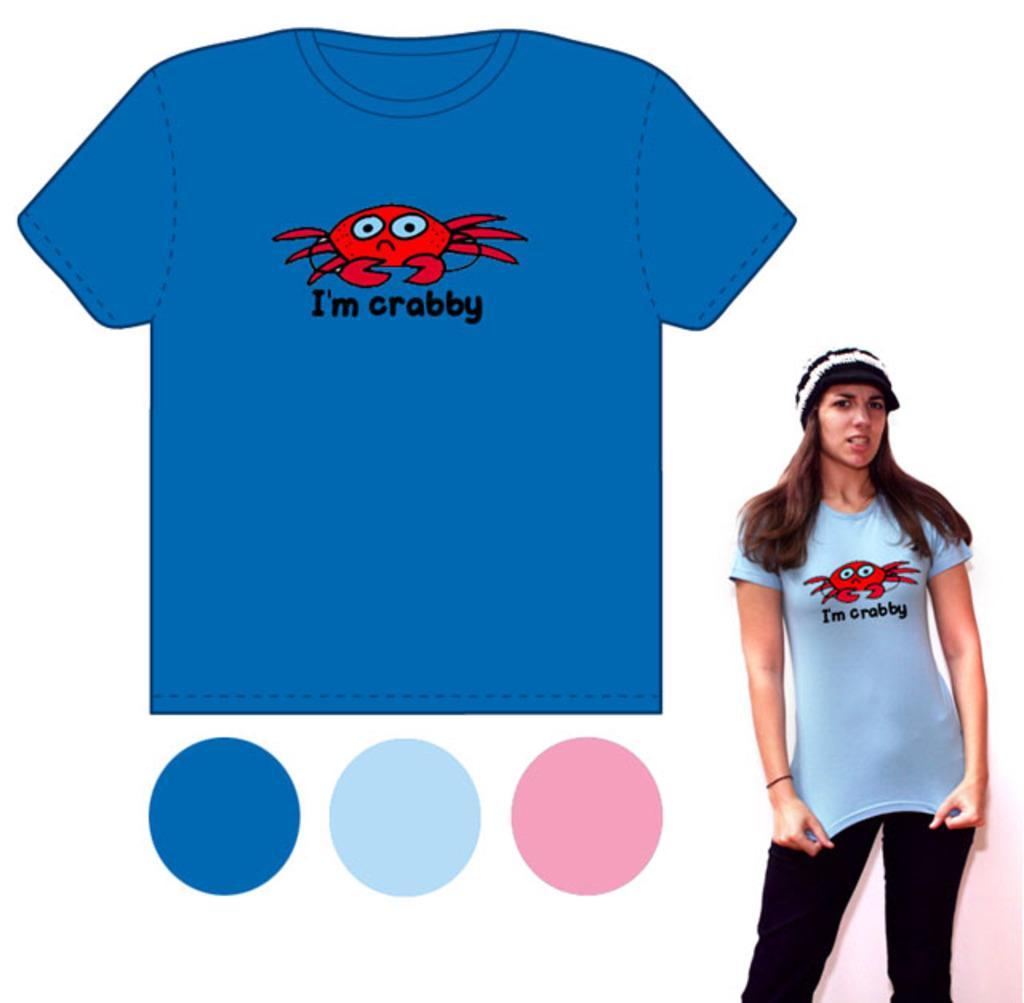How would you summarize this image in a sentence or two? In this picture I see there is a blue color t-shirt in the middle of an image. At the bottom there are 3 circles with different colors. On the right side a beautiful girl is standing, she wore blue color t-shirt with a red color crab on it, she wore a black color trouser and a white color cap. 